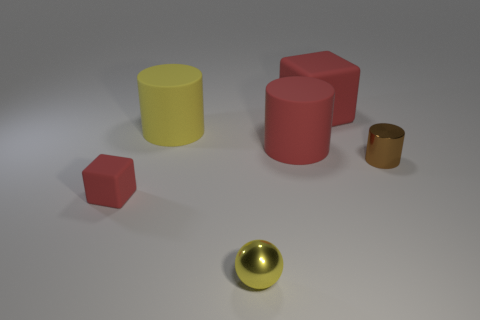Add 4 small brown matte things. How many objects exist? 10 Subtract all blocks. How many objects are left? 4 Subtract all brown shiny cylinders. Subtract all yellow things. How many objects are left? 3 Add 5 tiny red cubes. How many tiny red cubes are left? 6 Add 1 blue metal cylinders. How many blue metal cylinders exist? 1 Subtract 0 gray spheres. How many objects are left? 6 